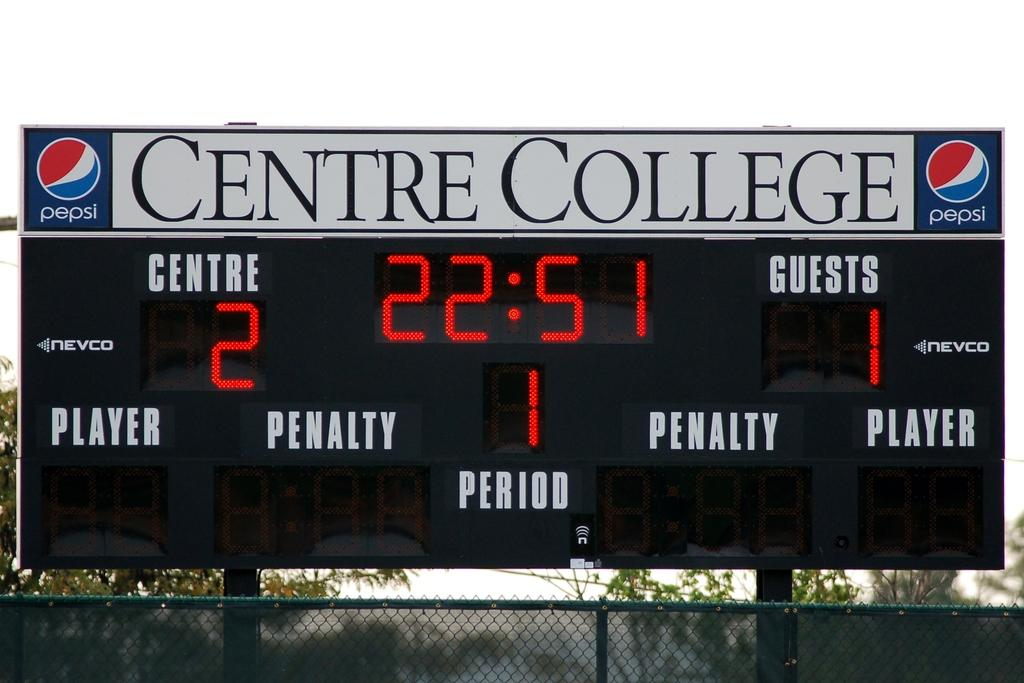<image>
Describe the image concisely. the time is 22:51 on the socreboard and it is 2 to 1 